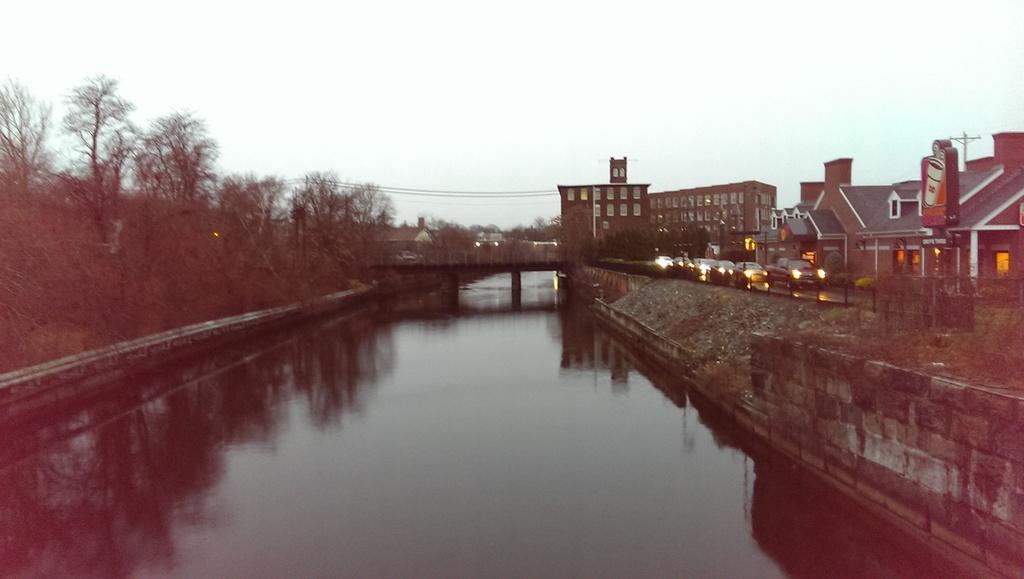In one or two sentences, can you explain what this image depicts? In this image, we can see trees, buildings, lights, poles and there are vehicles on the road and we can see a bridge. At the bottom, there is water and at the top, there is sky. 